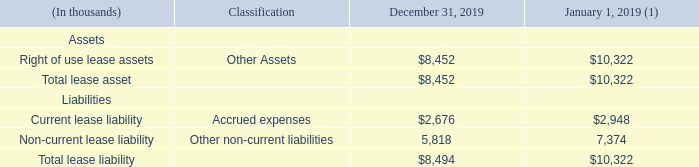Note 9 – Leases
We have operating leases for office space, automobiles and various other equipment in the U.S. and in certain international locations. We also reviewed other contracts, such as manufacturing agreements and service agreements, for potential embedded leases. We specifically reviewed these other contracts to determine whether we have the right to substantially all of the economic benefit from the use of any specified assets or the right to direct the use of any specified assets, either of which would indicate the existence of a lease.
As of December 31, 2019, our operating leases had remaining lease terms of one month to six years, some of which included options to extend the leases for up to nine years, and some of which included options to terminate the leases within three months. For those leases that are reasonably assured to be renewed, we have included the option to extend as part of our right of use asset and lease liability. Leases with an initial term of 12 months or less were not recorded on the balance sheet and lease expense for these leases is recognized on a straight-line basis over the lease term. Lease expense related to these short-term leases was $0.4 million for the twelve months ended December 31, 2019, and is included in cost of sales, selling, general and administrative expenses and research and development expenses in the Consolidated Statements of Income. Lease expense related to variable lease payments that do not depend on an index or rate, such as real estate taxes and insurance reimbursements, was $0.9 million for the twelve months ended December 31, 2019. For lease agreements entered into or reassessed after the adoption of Topic 842, we elected to not separate lease and nonlease components. Our lease agreements do not contain any material residual value guarantees or material restrictive covenants.
Supplemental balance sheet information related to operating leases is as follows:
(1) Reflects the adoption of the new lease accounting standard on January 1, 2019.
What types of operating leases does the company have in the U.S. and in certain international locations? Office space, automobiles and various other equipment. What was the right of use lease assets in December 2019?
Answer scale should be: thousand. $8,452. What was the current lease liability in December 2019?
Answer scale should be: thousand. $2,676. What was the change in current lease liability between January and December?
Answer scale should be: thousand. $2,676-$2,948
Answer: -272. What was the change in total lease asset between January and December?
Answer scale should be: thousand. $8,452-$10,322
Answer: -1870. What was the percentage change in total lease liability between January and December?
Answer scale should be: percent. ($8,494-$10,322)/$10,322
Answer: -17.71. 